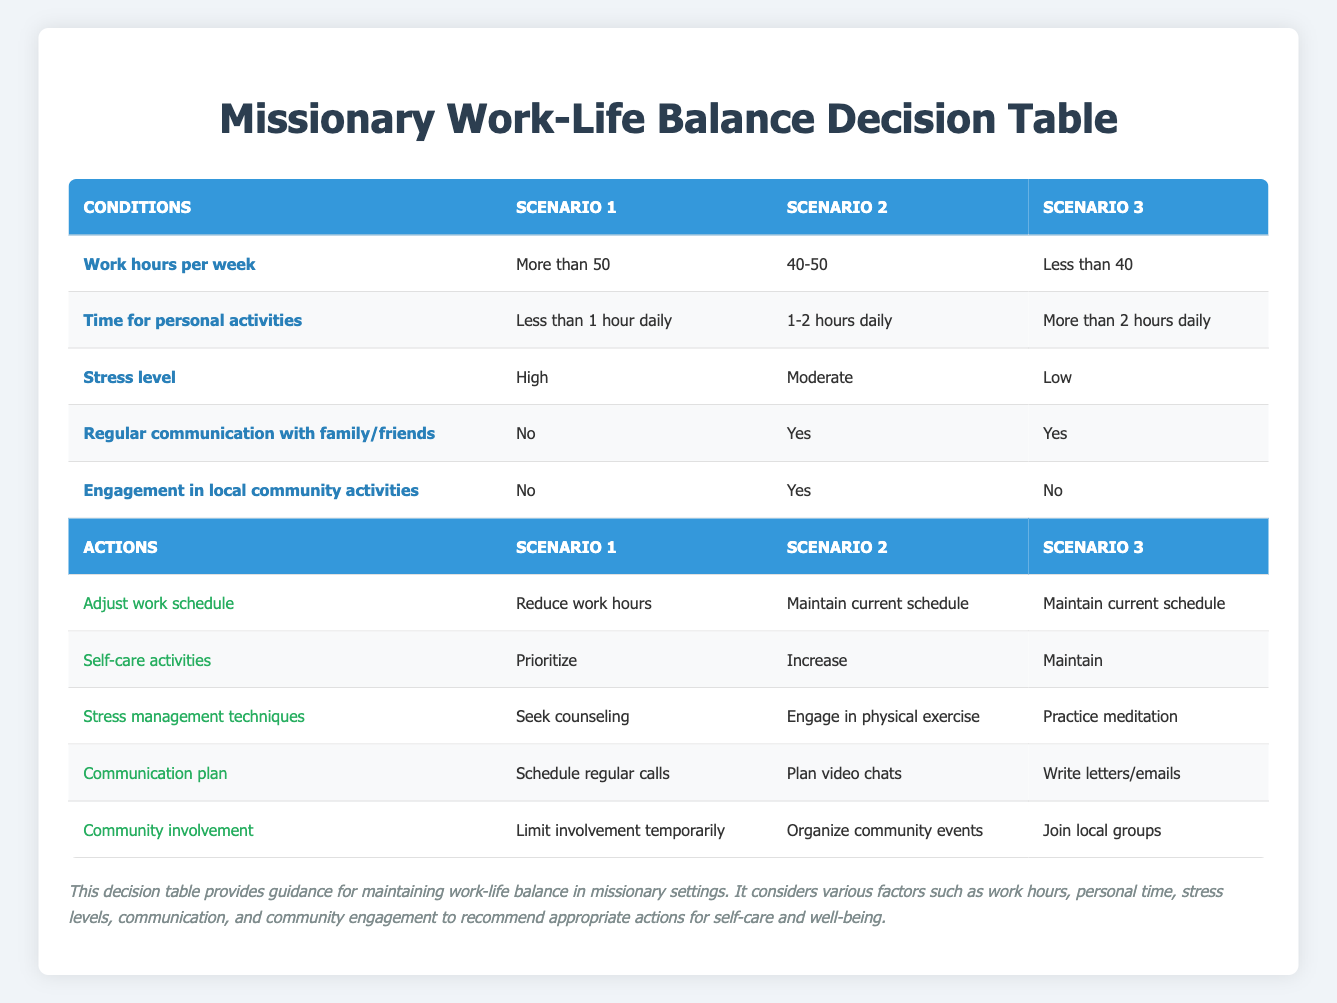What actions are recommended if someone works more than 50 hours a week with high stress and limited personal time? The table indicates that for the conditions of working more than 50 hours a week, having less than 1 hour for personal activities, high stress, no regular communication with family/friends, and no engagement in local community activities, the recommended actions are: Reduce work hours, Prioritize self-care activities, Seek counseling for stress management, Schedule regular calls for communication, and Limit community involvement temporarily.
Answer: Reduce work hours, Prioritize, Seek counseling, Schedule regular calls, Limit involvement temporarily How many conditions are yes for scenario 2? In scenario 2, the conditions are: 40-50 work hours, 1-2 hours for personal activities, moderate stress, regular communication with family/friends (yes), and engagement in local community activities (yes). The yes conditions are: regular communication and community engagement, making a total of 2 yes conditions.
Answer: 2 What is the self-care activity suggested for someone with less than 40 work hours and more than 2 hours for personal activities? The table indicates that if someone works less than 40 hours a week and has more than 2 hours for personal activities while maintaining low stress, regular communication with family/friends, and no local community engagement, the suggested self-care activity is to Maintain current self-care activities.
Answer: Maintain Which scenario has the highest stress level? According to the table, scenario 1 has the highest stress level indicated as High. This is determined by looking at the stress level row in each scenario, where scenario 1 is listed with a high stress level in comparison to the other two scenarios.
Answer: Scenario 1 If someone engages in local community activities but has 40-50 work hours and moderate stress level, what is the recommended communication plan? The table outlines that for the conditions of engaging in local community activities, working 40-50 hours, and having a moderate stress level with family/friends communication being yes, the recommended communication plan is to Plan video chats. This is derived from the row corresponding to these conditions.
Answer: Plan video chats If a person maintains their current work schedule but feels high stress, what should they do? The table specifies that if someone maintains their current work schedule and experiences high stress, they should seek counseling as a stress management technique and reduce work hours as part of adjusting their work schedule. Multiple actions are suggested based on the conditions relating to high stress and regular communication.
Answer: Seek counseling, Reduce work hours What is the community involvement action for someone working less than 40 hours a week and having low stress? The table shows that for conditions with less than 40 work hours per week and low stress, where there is regular communication with family/friends and no engagement in local community activities, the suggested community involvement action is to Join local groups, combing all relevant factors.
Answer: Join local groups What is the stress level for someone who spends less than 1 hour daily on personal activities while working more than 50 hours a week? The table indicates that for someone working more than 50 hours a week and spending less than 1 hour on personal activities, the stress level listed is High. This indicates a direct correlation between work hours and stress in this scenario.
Answer: High 